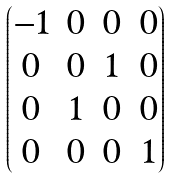Convert formula to latex. <formula><loc_0><loc_0><loc_500><loc_500>\begin{pmatrix} - 1 & 0 & 0 & 0 \\ 0 & 0 & 1 & 0 \\ 0 & 1 & 0 & 0 \\ 0 & 0 & 0 & 1 \\ \end{pmatrix}</formula> 